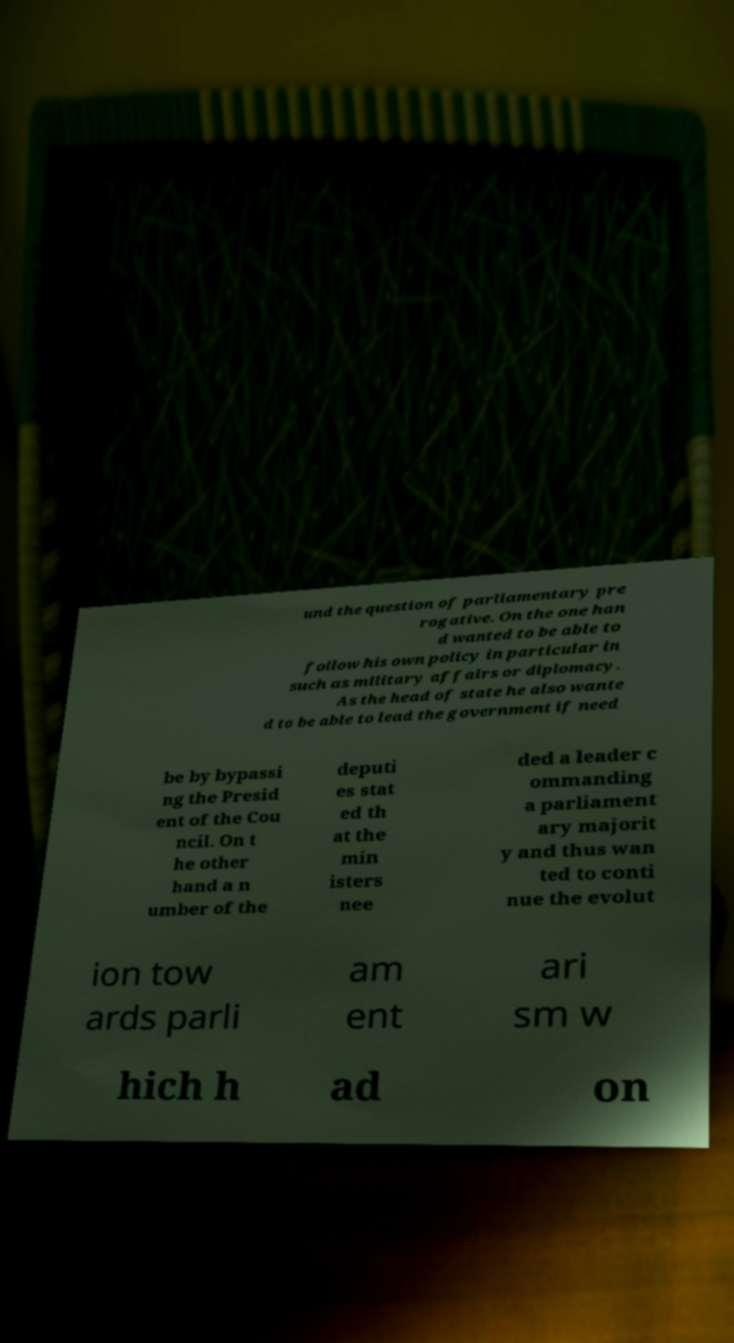Could you extract and type out the text from this image? und the question of parliamentary pre rogative. On the one han d wanted to be able to follow his own policy in particular in such as military affairs or diplomacy. As the head of state he also wante d to be able to lead the government if need be by bypassi ng the Presid ent of the Cou ncil. On t he other hand a n umber of the deputi es stat ed th at the min isters nee ded a leader c ommanding a parliament ary majorit y and thus wan ted to conti nue the evolut ion tow ards parli am ent ari sm w hich h ad on 